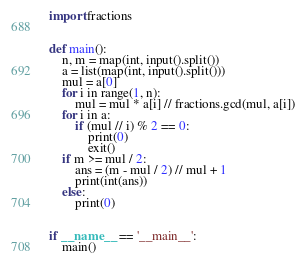Convert code to text. <code><loc_0><loc_0><loc_500><loc_500><_Python_>import fractions


def main():
    n, m = map(int, input().split())
    a = list(map(int, input().split()))
    mul = a[0]
    for i in range(1, n):
        mul = mul * a[i] // fractions.gcd(mul, a[i])
    for i in a:
        if (mul // i) % 2 == 0:
            print(0)
            exit()
    if m >= mul / 2:
        ans = (m - mul / 2) // mul + 1
        print(int(ans))
    else:
        print(0)


if __name__ == '__main__':
    main()
</code> 